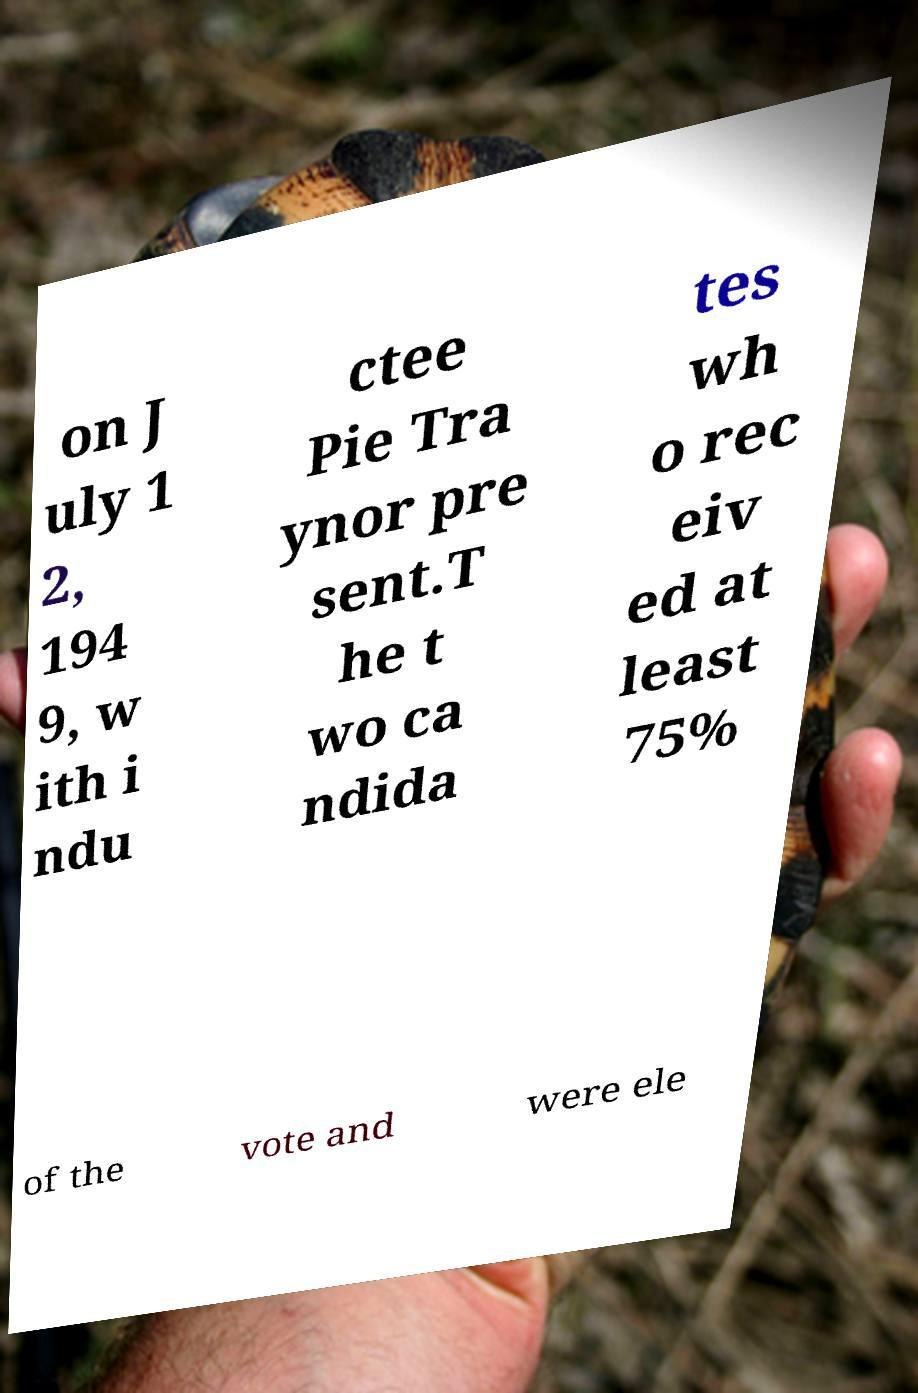Could you extract and type out the text from this image? on J uly 1 2, 194 9, w ith i ndu ctee Pie Tra ynor pre sent.T he t wo ca ndida tes wh o rec eiv ed at least 75% of the vote and were ele 